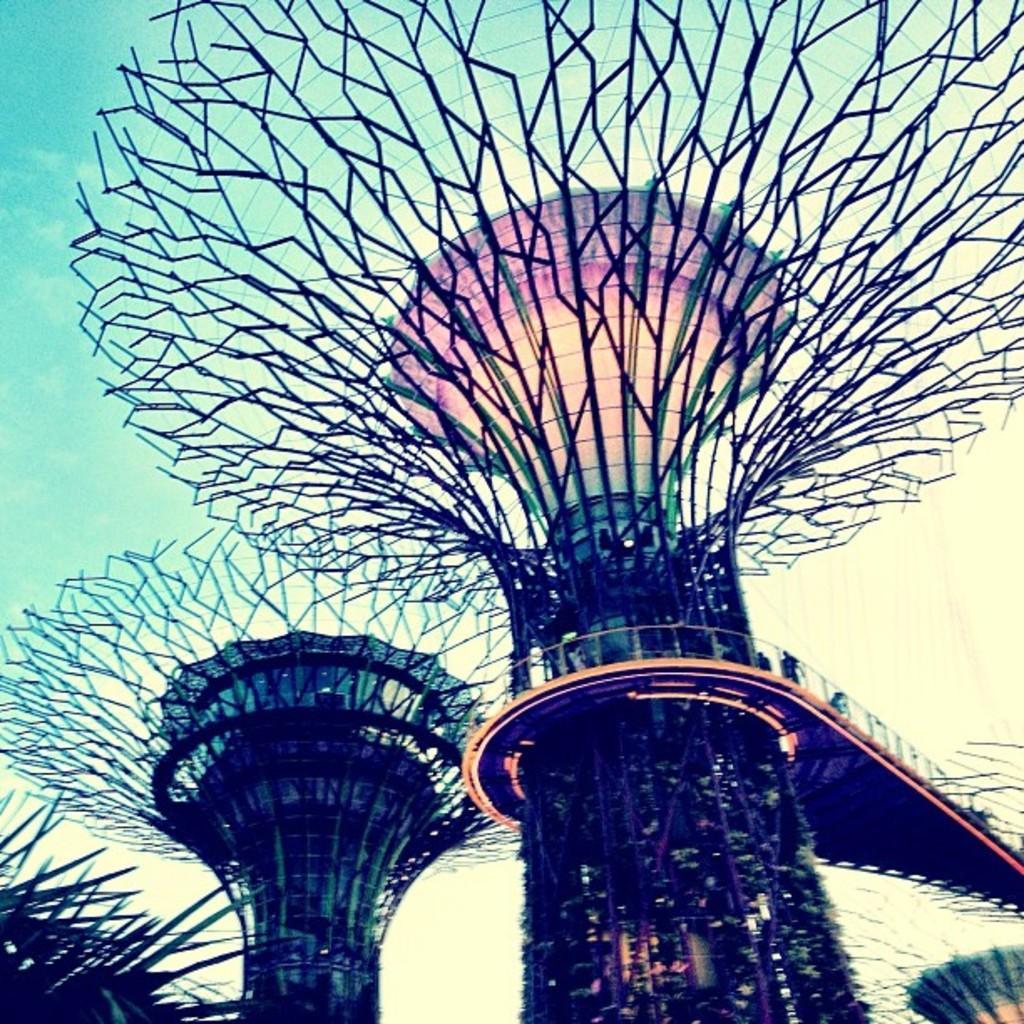How would you summarize this image in a sentence or two? In the image we can see bridge of modern architecture and the sky. 